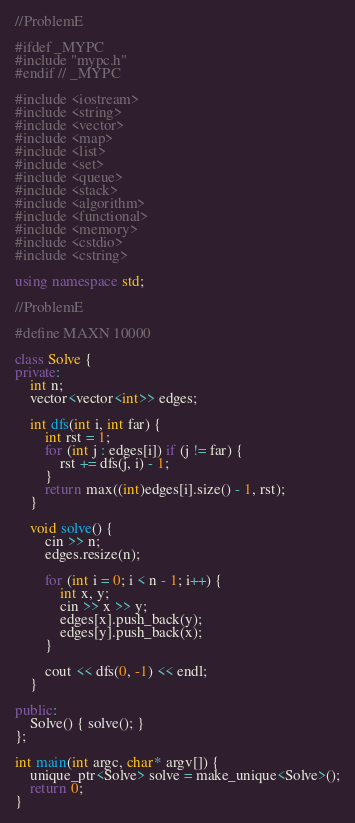<code> <loc_0><loc_0><loc_500><loc_500><_C++_>//ProblemE

#ifdef _MYPC
#include "mypc.h"
#endif // _MYPC

#include <iostream>
#include <string>
#include <vector>
#include <map>
#include <list>
#include <set>
#include <queue>
#include <stack>
#include <algorithm>
#include <functional>
#include <memory>
#include <cstdio>
#include <cstring>

using namespace std;

//ProblemE

#define MAXN 10000

class Solve {
private:
	int n;
	vector<vector<int>> edges;

	int dfs(int i, int far) {
		int rst = 1;
		for (int j : edges[i]) if (j != far) {
			rst += dfs(j, i) - 1;
		}
		return max((int)edges[i].size() - 1, rst);
	}

	void solve() {
		cin >> n;
		edges.resize(n);

		for (int i = 0; i < n - 1; i++) {
			int x, y;
			cin >> x >> y;
			edges[x].push_back(y);
			edges[y].push_back(x);
		}

		cout << dfs(0, -1) << endl;
	}

public:
	Solve() { solve(); }
};

int main(int argc, char* argv[]) {
	unique_ptr<Solve> solve = make_unique<Solve>();
	return 0;
}
</code> 